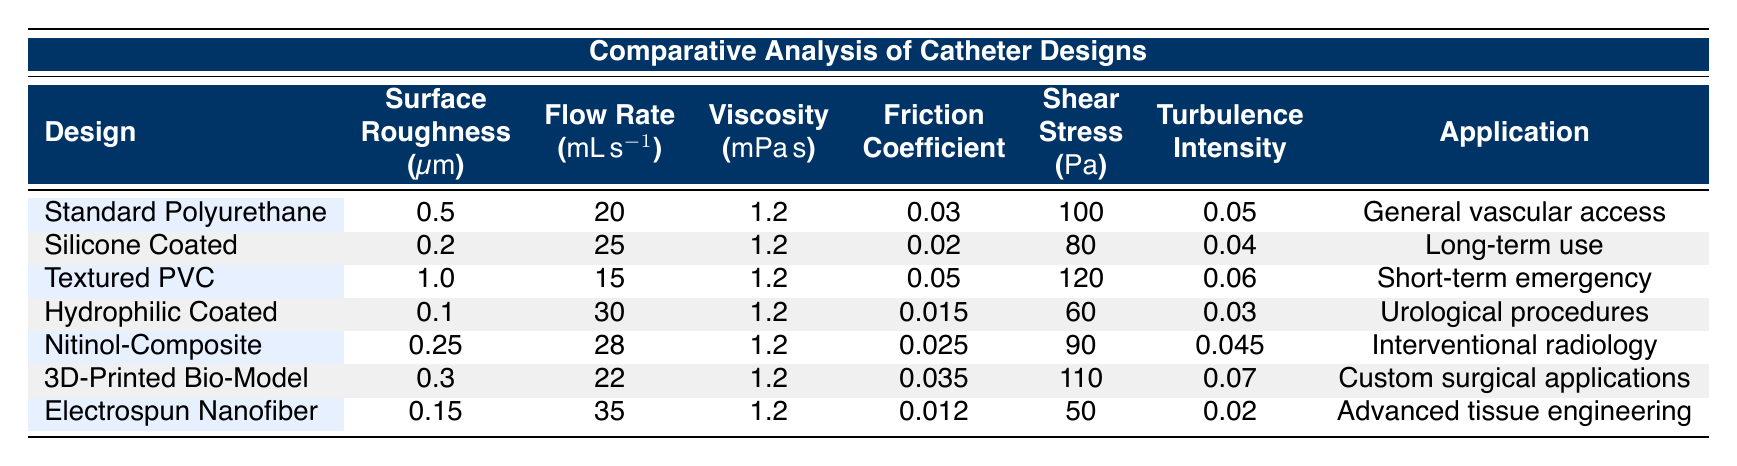What is the surface roughness of the Hydrophilic Coated Catheter? The table shows that the surface roughness for the Hydrophilic Coated Catheter is listed as 0.1 micrometers. I directly referred to the column under "Surface Roughness" corresponding to that design.
Answer: 0.1 Which catheter design has the highest flow rate? The flow rate column indicates that the Electrospun Nanofiber Catheter has the highest flow rate of 35 milliliters per second. By scanning through the flow rate values, I identified the maximum.
Answer: 35 What is the average surface roughness among all the catheter designs? To find the average surface roughness, I summed the roughness values: (0.5 + 0.2 + 1.0 + 0.1 + 0.25 + 0.3 + 0.15) = 2.55 micrometers. Then, I divided by the number of designs (7) to get the average: 2.55 / 7 = approximately 0.364.
Answer: 0.364 Is the friction coefficient of the Silicone Coated Catheter lower than 0.02? The table indicates that the friction coefficient for the Silicone Coated Catheter is precisely 0.02, thus it is not lower than that value. The "Friction Coefficient" column provided the data needed for this comparison.
Answer: No Which catheter design has the lowest shear stress, and what is its value? By examining the "Shear Stress" column, I found that the Hydrophilic Coated Catheter has the lowest value at 60 Pascals. I compared all values listed in that column to identify the minimum.
Answer: 60 How does the turbulence intensity of the Textured Polyvinyl Chloride Catheter compare to the Hydrophilic Coated Catheter? The Textured PVC Catheter has a turbulence intensity of 0.06, while the Hydrophilic Coated Catheter has a value of 0.03. Thus, the turbulence intensity in the Textured PVC design is higher than that in the Hydrophilic Coated design. I referred to the turbulence intensity values for comparison.
Answer: Higher What is the difference in flow rate between the 3D-Printed Bio-Model Catheter and the Silicone Coated Catheter? The flow rate for the 3D-Printed Bio-Model Catheter is 22 milliliters per second, while the Silicone Coated Catheter has a flow rate of 25 milliliters per second. When I calculate the difference, I get: 25 - 22 = 3 milliliters per second.
Answer: 3 Which catheter design is used for general vascular access? According to the application column in the table, the Standard Polyurethane Catheter is specified for general vascular access. I matched the application description to the correct catheter design.
Answer: Standard Polyurethane Catheter What is the highest shear stress recorded among all catheter designs? The shear stress values indicate that the Textured Polyvinyl Chloride Catheter has the highest shear stress at 120 Pascals. I looked through the shear stress column to find the maximum value present.
Answer: 120 